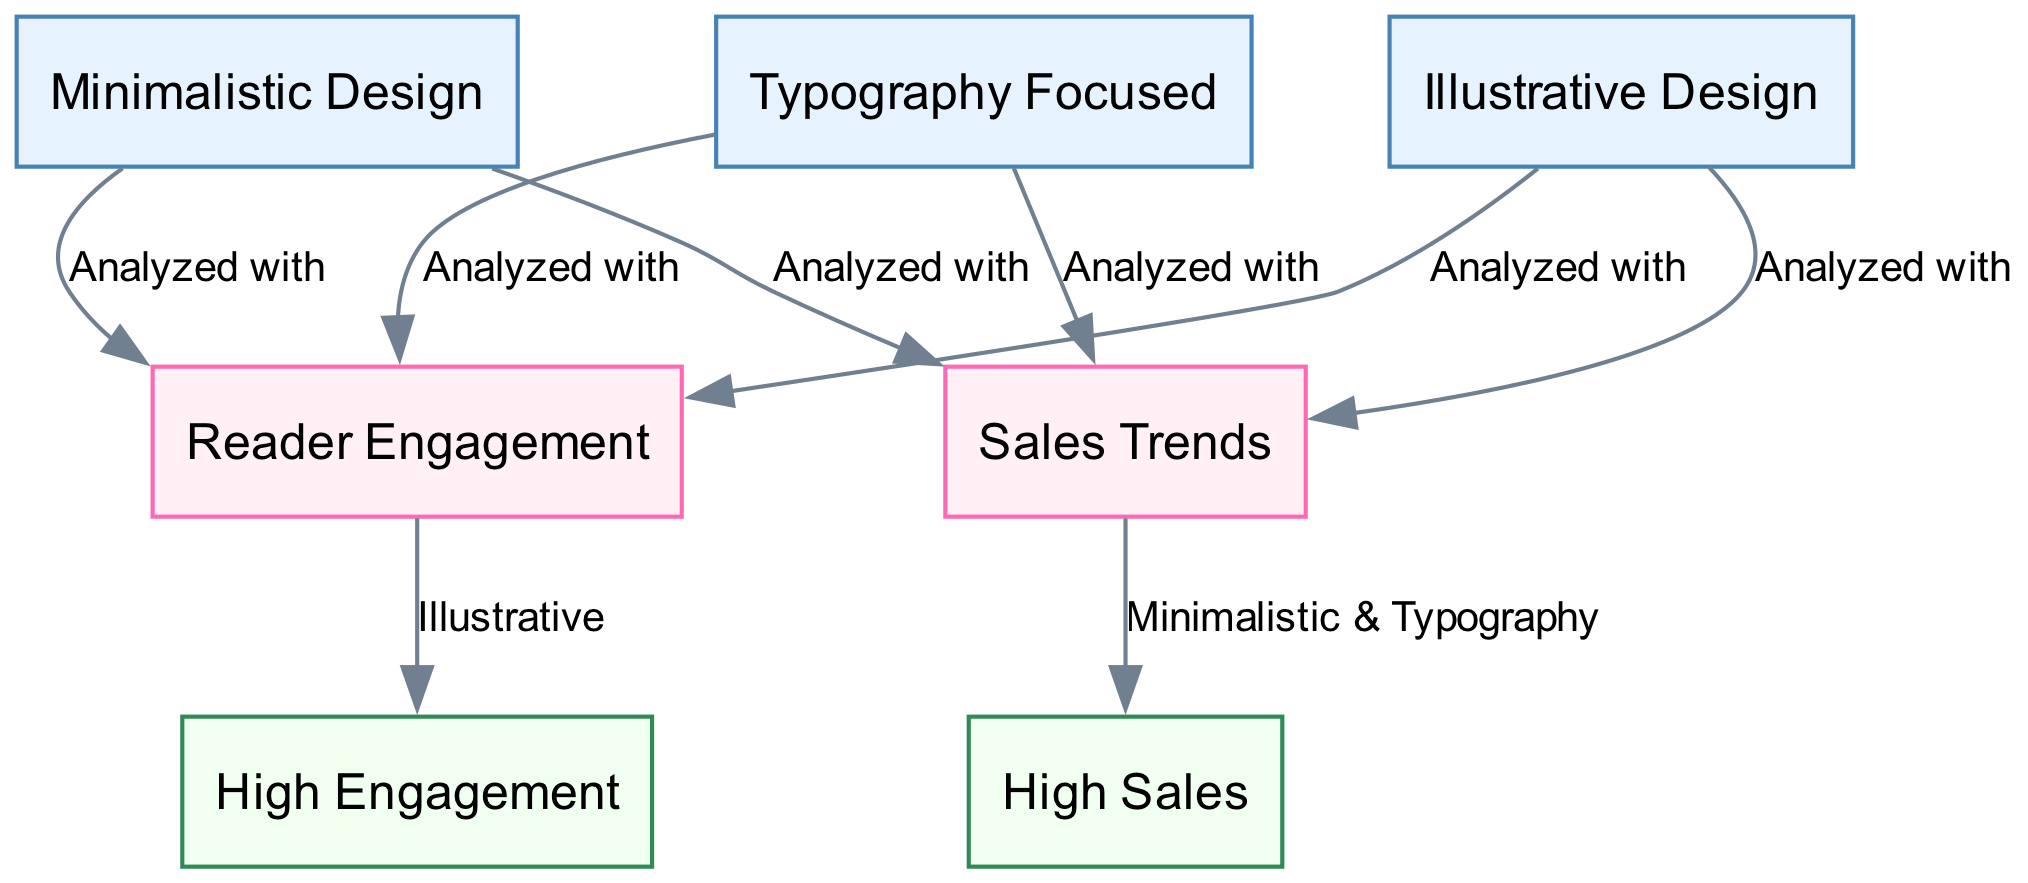What are the design styles analyzed in the diagram? The diagram includes three design styles: Minimalistic Design, Illustrative Design, and Typography Focused. Each is represented as a node connected to the analysis metrics.
Answer: Minimalistic Design, Illustrative Design, Typography Focused How many edges are present in the diagram? The diagram has a total of six edges connecting the design styles to the analysis metrics and two outcomes to those metrics. By counting both types, we arrive at a total of eight edges.
Answer: 8 Which design styles are associated with high sales? According to the diagram, both Minimalistic and Typography styles are connected to the high sales outcome through the sales trend metric.
Answer: Minimalistic, Typography What metric indicates high engagement and which design style is linked to it? The metric that indicates high engagement is reader engagement, and it is linked to the Illustrative Design style in the diagram.
Answer: Illustrative Which outcome is linked to the reader engagement metric? The outcome linked to the reader engagement metric is high engagement, indicated by an arrow connecting them in the diagram.
Answer: High Engagement What is the relationship between Minimalistic Design and sales trends? Minimalistic Design is analyzed with sales trends, indicating a direct relationship where both concepts are examined together for potential insights.
Answer: Analyzed with Which design style is linked directly to both sales trends and reader engagement? All three design styles—Minimalistic Design, Illustrative Design, and Typography Focused—are linked directly to both sales trends and reader engagement in the diagram.
Answer: All three styles How does the diagram represent the flow of analysis from design styles to outcomes? The diagram represents the flow of analysis by having arrows connect design styles to their corresponding analysis metrics, and from those metrics to the resulting outcomes, showing a clear path of analysis.
Answer: Through arrows 